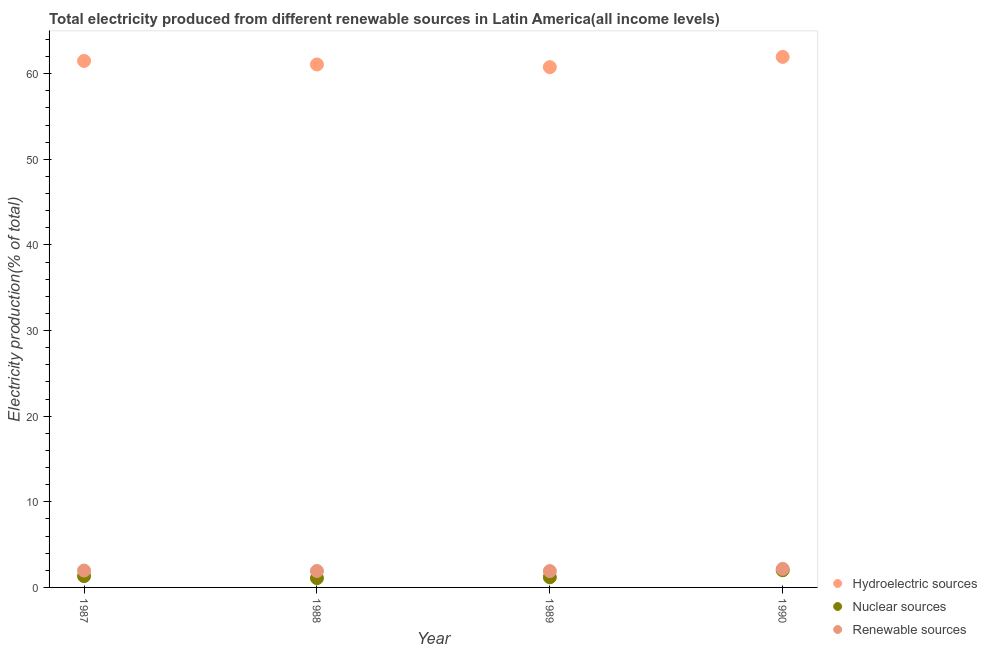How many different coloured dotlines are there?
Keep it short and to the point. 3. Is the number of dotlines equal to the number of legend labels?
Make the answer very short. Yes. What is the percentage of electricity produced by renewable sources in 1990?
Your response must be concise. 2.16. Across all years, what is the maximum percentage of electricity produced by hydroelectric sources?
Make the answer very short. 61.96. Across all years, what is the minimum percentage of electricity produced by nuclear sources?
Ensure brevity in your answer.  1.09. What is the total percentage of electricity produced by hydroelectric sources in the graph?
Your answer should be compact. 245.29. What is the difference between the percentage of electricity produced by nuclear sources in 1988 and that in 1990?
Offer a terse response. -0.92. What is the difference between the percentage of electricity produced by renewable sources in 1989 and the percentage of electricity produced by nuclear sources in 1988?
Make the answer very short. 0.82. What is the average percentage of electricity produced by nuclear sources per year?
Provide a succinct answer. 1.4. In the year 1990, what is the difference between the percentage of electricity produced by renewable sources and percentage of electricity produced by nuclear sources?
Your response must be concise. 0.16. What is the ratio of the percentage of electricity produced by hydroelectric sources in 1988 to that in 1990?
Keep it short and to the point. 0.99. What is the difference between the highest and the second highest percentage of electricity produced by renewable sources?
Offer a very short reply. 0.19. What is the difference between the highest and the lowest percentage of electricity produced by nuclear sources?
Ensure brevity in your answer.  0.92. Is the percentage of electricity produced by renewable sources strictly less than the percentage of electricity produced by hydroelectric sources over the years?
Keep it short and to the point. Yes. How many dotlines are there?
Your answer should be very brief. 3. Does the graph contain grids?
Your answer should be compact. No. Where does the legend appear in the graph?
Your answer should be compact. Bottom right. How many legend labels are there?
Give a very brief answer. 3. How are the legend labels stacked?
Ensure brevity in your answer.  Vertical. What is the title of the graph?
Your response must be concise. Total electricity produced from different renewable sources in Latin America(all income levels). What is the Electricity production(% of total) of Hydroelectric sources in 1987?
Your answer should be very brief. 61.49. What is the Electricity production(% of total) of Nuclear sources in 1987?
Make the answer very short. 1.32. What is the Electricity production(% of total) of Renewable sources in 1987?
Your response must be concise. 1.97. What is the Electricity production(% of total) of Hydroelectric sources in 1988?
Your answer should be very brief. 61.08. What is the Electricity production(% of total) in Nuclear sources in 1988?
Keep it short and to the point. 1.09. What is the Electricity production(% of total) of Renewable sources in 1988?
Offer a terse response. 1.92. What is the Electricity production(% of total) in Hydroelectric sources in 1989?
Provide a short and direct response. 60.76. What is the Electricity production(% of total) in Nuclear sources in 1989?
Keep it short and to the point. 1.19. What is the Electricity production(% of total) of Renewable sources in 1989?
Make the answer very short. 1.91. What is the Electricity production(% of total) in Hydroelectric sources in 1990?
Provide a short and direct response. 61.96. What is the Electricity production(% of total) of Nuclear sources in 1990?
Provide a short and direct response. 2.01. What is the Electricity production(% of total) in Renewable sources in 1990?
Your response must be concise. 2.16. Across all years, what is the maximum Electricity production(% of total) in Hydroelectric sources?
Offer a very short reply. 61.96. Across all years, what is the maximum Electricity production(% of total) in Nuclear sources?
Provide a short and direct response. 2.01. Across all years, what is the maximum Electricity production(% of total) of Renewable sources?
Offer a very short reply. 2.16. Across all years, what is the minimum Electricity production(% of total) in Hydroelectric sources?
Your response must be concise. 60.76. Across all years, what is the minimum Electricity production(% of total) in Nuclear sources?
Offer a very short reply. 1.09. Across all years, what is the minimum Electricity production(% of total) in Renewable sources?
Give a very brief answer. 1.91. What is the total Electricity production(% of total) in Hydroelectric sources in the graph?
Keep it short and to the point. 245.29. What is the total Electricity production(% of total) in Nuclear sources in the graph?
Provide a short and direct response. 5.6. What is the total Electricity production(% of total) of Renewable sources in the graph?
Make the answer very short. 7.96. What is the difference between the Electricity production(% of total) of Hydroelectric sources in 1987 and that in 1988?
Offer a terse response. 0.41. What is the difference between the Electricity production(% of total) in Nuclear sources in 1987 and that in 1988?
Offer a very short reply. 0.23. What is the difference between the Electricity production(% of total) of Renewable sources in 1987 and that in 1988?
Provide a short and direct response. 0.05. What is the difference between the Electricity production(% of total) in Hydroelectric sources in 1987 and that in 1989?
Offer a very short reply. 0.73. What is the difference between the Electricity production(% of total) of Nuclear sources in 1987 and that in 1989?
Offer a very short reply. 0.13. What is the difference between the Electricity production(% of total) of Renewable sources in 1987 and that in 1989?
Offer a very short reply. 0.06. What is the difference between the Electricity production(% of total) of Hydroelectric sources in 1987 and that in 1990?
Offer a very short reply. -0.47. What is the difference between the Electricity production(% of total) in Nuclear sources in 1987 and that in 1990?
Make the answer very short. -0.69. What is the difference between the Electricity production(% of total) of Renewable sources in 1987 and that in 1990?
Your answer should be compact. -0.19. What is the difference between the Electricity production(% of total) of Hydroelectric sources in 1988 and that in 1989?
Give a very brief answer. 0.31. What is the difference between the Electricity production(% of total) in Nuclear sources in 1988 and that in 1989?
Your response must be concise. -0.1. What is the difference between the Electricity production(% of total) of Renewable sources in 1988 and that in 1989?
Keep it short and to the point. 0.01. What is the difference between the Electricity production(% of total) in Hydroelectric sources in 1988 and that in 1990?
Ensure brevity in your answer.  -0.89. What is the difference between the Electricity production(% of total) in Nuclear sources in 1988 and that in 1990?
Ensure brevity in your answer.  -0.92. What is the difference between the Electricity production(% of total) in Renewable sources in 1988 and that in 1990?
Provide a succinct answer. -0.25. What is the difference between the Electricity production(% of total) of Hydroelectric sources in 1989 and that in 1990?
Your answer should be very brief. -1.2. What is the difference between the Electricity production(% of total) in Nuclear sources in 1989 and that in 1990?
Provide a short and direct response. -0.82. What is the difference between the Electricity production(% of total) of Renewable sources in 1989 and that in 1990?
Your answer should be compact. -0.26. What is the difference between the Electricity production(% of total) in Hydroelectric sources in 1987 and the Electricity production(% of total) in Nuclear sources in 1988?
Give a very brief answer. 60.4. What is the difference between the Electricity production(% of total) of Hydroelectric sources in 1987 and the Electricity production(% of total) of Renewable sources in 1988?
Ensure brevity in your answer.  59.57. What is the difference between the Electricity production(% of total) of Nuclear sources in 1987 and the Electricity production(% of total) of Renewable sources in 1988?
Your response must be concise. -0.6. What is the difference between the Electricity production(% of total) of Hydroelectric sources in 1987 and the Electricity production(% of total) of Nuclear sources in 1989?
Provide a succinct answer. 60.3. What is the difference between the Electricity production(% of total) of Hydroelectric sources in 1987 and the Electricity production(% of total) of Renewable sources in 1989?
Make the answer very short. 59.58. What is the difference between the Electricity production(% of total) in Nuclear sources in 1987 and the Electricity production(% of total) in Renewable sources in 1989?
Your response must be concise. -0.59. What is the difference between the Electricity production(% of total) in Hydroelectric sources in 1987 and the Electricity production(% of total) in Nuclear sources in 1990?
Offer a very short reply. 59.49. What is the difference between the Electricity production(% of total) in Hydroelectric sources in 1987 and the Electricity production(% of total) in Renewable sources in 1990?
Make the answer very short. 59.33. What is the difference between the Electricity production(% of total) in Nuclear sources in 1987 and the Electricity production(% of total) in Renewable sources in 1990?
Make the answer very short. -0.84. What is the difference between the Electricity production(% of total) of Hydroelectric sources in 1988 and the Electricity production(% of total) of Nuclear sources in 1989?
Make the answer very short. 59.89. What is the difference between the Electricity production(% of total) in Hydroelectric sources in 1988 and the Electricity production(% of total) in Renewable sources in 1989?
Provide a short and direct response. 59.17. What is the difference between the Electricity production(% of total) in Nuclear sources in 1988 and the Electricity production(% of total) in Renewable sources in 1989?
Offer a very short reply. -0.82. What is the difference between the Electricity production(% of total) of Hydroelectric sources in 1988 and the Electricity production(% of total) of Nuclear sources in 1990?
Offer a very short reply. 59.07. What is the difference between the Electricity production(% of total) of Hydroelectric sources in 1988 and the Electricity production(% of total) of Renewable sources in 1990?
Your answer should be compact. 58.91. What is the difference between the Electricity production(% of total) of Nuclear sources in 1988 and the Electricity production(% of total) of Renewable sources in 1990?
Provide a short and direct response. -1.08. What is the difference between the Electricity production(% of total) of Hydroelectric sources in 1989 and the Electricity production(% of total) of Nuclear sources in 1990?
Ensure brevity in your answer.  58.76. What is the difference between the Electricity production(% of total) in Hydroelectric sources in 1989 and the Electricity production(% of total) in Renewable sources in 1990?
Give a very brief answer. 58.6. What is the difference between the Electricity production(% of total) in Nuclear sources in 1989 and the Electricity production(% of total) in Renewable sources in 1990?
Offer a very short reply. -0.98. What is the average Electricity production(% of total) of Hydroelectric sources per year?
Your answer should be very brief. 61.32. What is the average Electricity production(% of total) in Nuclear sources per year?
Provide a short and direct response. 1.4. What is the average Electricity production(% of total) of Renewable sources per year?
Your response must be concise. 1.99. In the year 1987, what is the difference between the Electricity production(% of total) in Hydroelectric sources and Electricity production(% of total) in Nuclear sources?
Make the answer very short. 60.17. In the year 1987, what is the difference between the Electricity production(% of total) in Hydroelectric sources and Electricity production(% of total) in Renewable sources?
Make the answer very short. 59.52. In the year 1987, what is the difference between the Electricity production(% of total) of Nuclear sources and Electricity production(% of total) of Renewable sources?
Give a very brief answer. -0.65. In the year 1988, what is the difference between the Electricity production(% of total) of Hydroelectric sources and Electricity production(% of total) of Nuclear sources?
Provide a succinct answer. 59.99. In the year 1988, what is the difference between the Electricity production(% of total) of Hydroelectric sources and Electricity production(% of total) of Renewable sources?
Provide a succinct answer. 59.16. In the year 1988, what is the difference between the Electricity production(% of total) in Nuclear sources and Electricity production(% of total) in Renewable sources?
Make the answer very short. -0.83. In the year 1989, what is the difference between the Electricity production(% of total) of Hydroelectric sources and Electricity production(% of total) of Nuclear sources?
Ensure brevity in your answer.  59.58. In the year 1989, what is the difference between the Electricity production(% of total) in Hydroelectric sources and Electricity production(% of total) in Renewable sources?
Make the answer very short. 58.85. In the year 1989, what is the difference between the Electricity production(% of total) of Nuclear sources and Electricity production(% of total) of Renewable sources?
Make the answer very short. -0.72. In the year 1990, what is the difference between the Electricity production(% of total) in Hydroelectric sources and Electricity production(% of total) in Nuclear sources?
Your response must be concise. 59.96. In the year 1990, what is the difference between the Electricity production(% of total) of Hydroelectric sources and Electricity production(% of total) of Renewable sources?
Your answer should be compact. 59.8. In the year 1990, what is the difference between the Electricity production(% of total) of Nuclear sources and Electricity production(% of total) of Renewable sources?
Provide a succinct answer. -0.16. What is the ratio of the Electricity production(% of total) in Hydroelectric sources in 1987 to that in 1988?
Your response must be concise. 1.01. What is the ratio of the Electricity production(% of total) of Nuclear sources in 1987 to that in 1988?
Your response must be concise. 1.22. What is the ratio of the Electricity production(% of total) in Renewable sources in 1987 to that in 1988?
Make the answer very short. 1.03. What is the ratio of the Electricity production(% of total) in Hydroelectric sources in 1987 to that in 1989?
Your answer should be compact. 1.01. What is the ratio of the Electricity production(% of total) of Nuclear sources in 1987 to that in 1989?
Ensure brevity in your answer.  1.11. What is the ratio of the Electricity production(% of total) of Renewable sources in 1987 to that in 1989?
Your response must be concise. 1.03. What is the ratio of the Electricity production(% of total) in Nuclear sources in 1987 to that in 1990?
Your response must be concise. 0.66. What is the ratio of the Electricity production(% of total) in Renewable sources in 1987 to that in 1990?
Give a very brief answer. 0.91. What is the ratio of the Electricity production(% of total) of Nuclear sources in 1988 to that in 1989?
Your answer should be very brief. 0.92. What is the ratio of the Electricity production(% of total) of Renewable sources in 1988 to that in 1989?
Your answer should be compact. 1. What is the ratio of the Electricity production(% of total) in Hydroelectric sources in 1988 to that in 1990?
Give a very brief answer. 0.99. What is the ratio of the Electricity production(% of total) of Nuclear sources in 1988 to that in 1990?
Provide a short and direct response. 0.54. What is the ratio of the Electricity production(% of total) in Renewable sources in 1988 to that in 1990?
Your answer should be compact. 0.89. What is the ratio of the Electricity production(% of total) in Hydroelectric sources in 1989 to that in 1990?
Provide a succinct answer. 0.98. What is the ratio of the Electricity production(% of total) in Nuclear sources in 1989 to that in 1990?
Ensure brevity in your answer.  0.59. What is the ratio of the Electricity production(% of total) of Renewable sources in 1989 to that in 1990?
Keep it short and to the point. 0.88. What is the difference between the highest and the second highest Electricity production(% of total) of Hydroelectric sources?
Give a very brief answer. 0.47. What is the difference between the highest and the second highest Electricity production(% of total) of Nuclear sources?
Provide a short and direct response. 0.69. What is the difference between the highest and the second highest Electricity production(% of total) of Renewable sources?
Give a very brief answer. 0.19. What is the difference between the highest and the lowest Electricity production(% of total) in Hydroelectric sources?
Keep it short and to the point. 1.2. What is the difference between the highest and the lowest Electricity production(% of total) in Nuclear sources?
Your response must be concise. 0.92. What is the difference between the highest and the lowest Electricity production(% of total) of Renewable sources?
Offer a terse response. 0.26. 